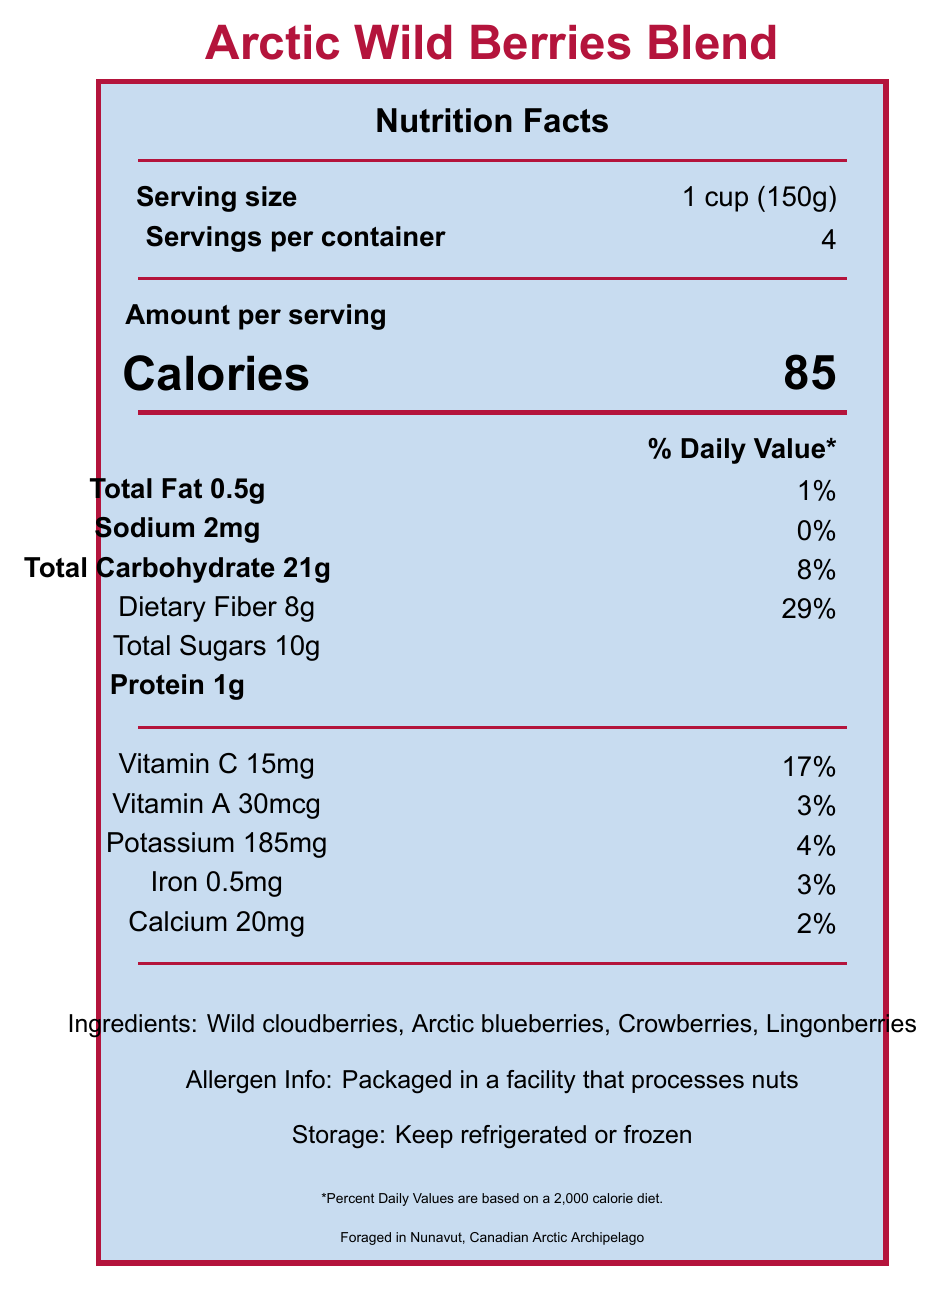what is the serving size? The serving size is explicitly mentioned as "1 cup (150g)" in the document.
Answer: 1 cup (150g) how many servings are there per container? The document states "Servings per container: 4".
Answer: 4 what is the calorie content per serving? The calorie content is listed as "Calories 85" per serving.
Answer: 85 calories how much dietary fiber does one serving contain? It mentions "Dietary Fiber 8g".
Answer: 8g what is the foraging location of the berries? The document specifies that the berries were foraged in "Nunavut, Canadian Arctic Archipelago".
Answer: Nunavut, Canadian Arctic Archipelago how much protein is there in a serving? The document notes "Protein 1g" per serving.
Answer: 1g what are the ingredients of the berry blend? The ingredients listed are "Wild cloudberries, Arctic blueberries, Crowberries, Lingonberries".
Answer: Wild cloudberries, Arctic blueberries, Crowberries, Lingonberries which vitamin is present in the highest percentage of the daily value? A. Vitamin C B. Vitamin A C. Iron D. Calcium The document shows Vitamin C with a daily value percentage of 17%, which is higher than the daily values of Vitamin A, Iron, and Calcium.
Answer: A. Vitamin C how is the product meant to be stored? A. Keep at room temperature B. Keep refrigerated or frozen C. Keep in a cool, dry place D. Keep away from direct sunlight The storage instructions clearly state "Keep refrigerated or frozen."
Answer: B. Keep refrigerated or frozen is this product suitable for someone with a nut allergy? It mentions "Packaged in a facility that processes nuts," indicating potential cross-contamination with nuts.
Answer: No does the product contain any sodium? It lists "Sodium 2mg."
Answer: Yes summarize the main idea of the document The document covers comprehensive data on the Arctic Wild Berries Blend's nutritional facts, ingredients, storage, foraging location, and additional notes on health and survival.
Answer: The document provides nutritional information for the Arctic Wild Berries Blend, including serving size, calorie count, macronutrients, vitamins, and minerals. The ingredients are various types of berries foraged from the Canadian Arctic. It also includes storage instructions, allergen information, and some survival tips and health benefits. how much potassium is in one serving of the berries? The document states that there are 185mg of potassium per serving.
Answer: 185mg what survival tips are included in the document? The document lists three survival tips specifically related to foraging and consuming these wild berries.
Answer: Always verify berry identification before consuming, Avoid berries growing near polluted areas, Consume in moderation to prevent digestive issues can this product be kept at room temperature? Storage instructions specifically state to keep it refrigerated or frozen, indicating room temperature is not suitable.
Answer: No identify a health benefit mentioned for the berries One of the health benefits listed is "High in antioxidants."
Answer: High in antioxidants what is the amount of total sugars in a serving? The document notes "Total Sugars 10g."
Answer: 10g what is the total amount of total carbohydrates in one serving? The document specifies "Total Carbohydrate 21g."
Answer: 21g what kind of vitamins are listed in the document? The vitamins listed in the nutritional facts are Vitamin C and Vitamin A.
Answer: Vitamin C, Vitamin A how much iron does one serving contain? The document indicates that each serving has 0.5mg of iron.
Answer: 0.5mg how many ingredients are listed in the document? The document lists four ingredients: Wild cloudberries, Arctic blueberries, Crowberries, Lingonberries.
Answer: 4 what was the purpose of foraging these berries as mentioned in the document? The instructor notes state these berries were foraged during an Arctic survival challenge for their essential nutrients.
Answer: They provided essential nutrients during the Arctic survival challenge when other food sources were scarce. what is the blend's daily value percentage of calcium per serving? The document lists the daily value percentage of calcium as 2%.
Answer: 2% which berry in the blend is not typically available in the common supermarket? A. Wild cloudberries B. Arctic blueberries C. Crowberries D. Lingonberries Wild cloudberries are less commonly available in supermarkets compared to other berries in the blend.
Answer: A. Wild cloudberries what is the dosing recommendation for the serving size of the blend? The document does not provide a dosing recommendation, only the serving size.
Answer: Cannot be determined how much total fat is there in a serving? It mentions "Total Fat 0.5g."
Answer: 0.5g is there more total carbohydrate or dietary fiber in a serving? The total carbohydrate content is 21g while dietary fiber is 8g, making the total carbohydrate higher.
Answer: Total carbohydrate 